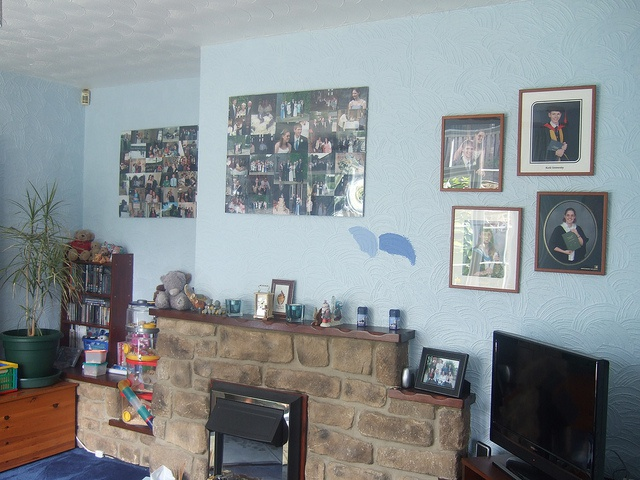Describe the objects in this image and their specific colors. I can see tv in gray, black, and darkblue tones, potted plant in gray and black tones, people in gray, purple, and darkgray tones, people in gray, black, darkgray, and darkblue tones, and teddy bear in gray tones in this image. 